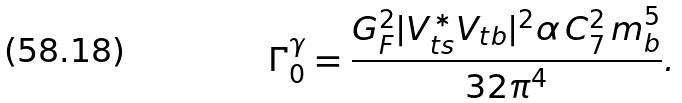Convert formula to latex. <formula><loc_0><loc_0><loc_500><loc_500>\Gamma ^ { \gamma } _ { 0 } = \frac { G _ { F } ^ { 2 } | V _ { t s } ^ { * } V _ { t b } | ^ { 2 } \alpha \, C _ { 7 } ^ { 2 } \, m _ { b } ^ { 5 } } { 3 2 \pi ^ { 4 } } .</formula> 